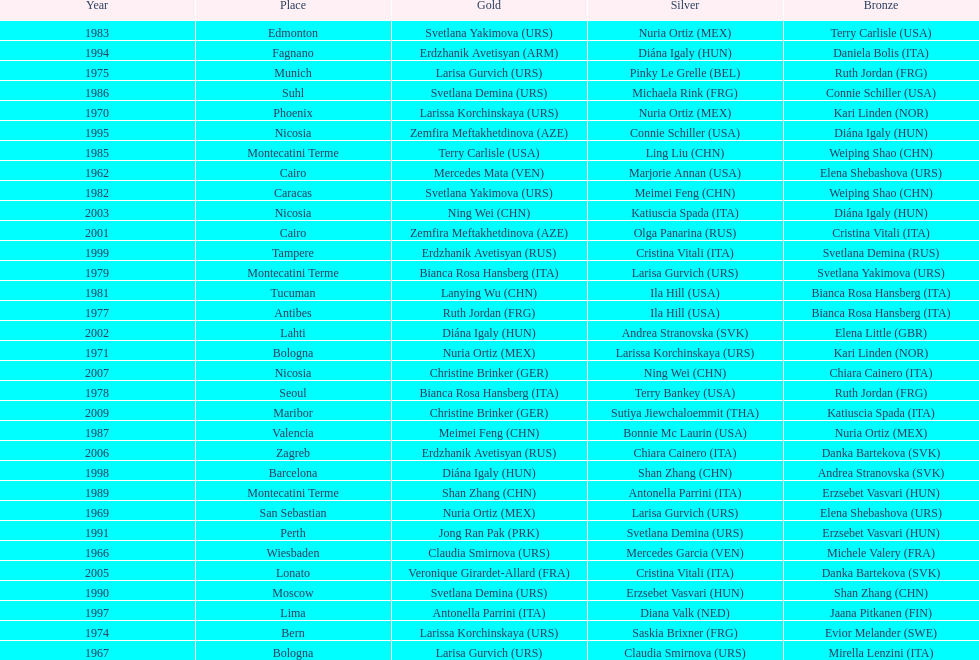What is the total of silver for cairo 0. Could you parse the entire table as a dict? {'header': ['Year', 'Place', 'Gold', 'Silver', 'Bronze'], 'rows': [['1983', 'Edmonton', 'Svetlana Yakimova\xa0(URS)', 'Nuria Ortiz\xa0(MEX)', 'Terry Carlisle\xa0(USA)'], ['1994', 'Fagnano', 'Erdzhanik Avetisyan\xa0(ARM)', 'Diána Igaly\xa0(HUN)', 'Daniela Bolis\xa0(ITA)'], ['1975', 'Munich', 'Larisa Gurvich\xa0(URS)', 'Pinky Le Grelle\xa0(BEL)', 'Ruth Jordan\xa0(FRG)'], ['1986', 'Suhl', 'Svetlana Demina\xa0(URS)', 'Michaela Rink\xa0(FRG)', 'Connie Schiller\xa0(USA)'], ['1970', 'Phoenix', 'Larissa Korchinskaya\xa0(URS)', 'Nuria Ortiz\xa0(MEX)', 'Kari Linden\xa0(NOR)'], ['1995', 'Nicosia', 'Zemfira Meftakhetdinova\xa0(AZE)', 'Connie Schiller\xa0(USA)', 'Diána Igaly\xa0(HUN)'], ['1985', 'Montecatini Terme', 'Terry Carlisle\xa0(USA)', 'Ling Liu\xa0(CHN)', 'Weiping Shao\xa0(CHN)'], ['1962', 'Cairo', 'Mercedes Mata\xa0(VEN)', 'Marjorie Annan\xa0(USA)', 'Elena Shebashova\xa0(URS)'], ['1982', 'Caracas', 'Svetlana Yakimova\xa0(URS)', 'Meimei Feng\xa0(CHN)', 'Weiping Shao\xa0(CHN)'], ['2003', 'Nicosia', 'Ning Wei\xa0(CHN)', 'Katiuscia Spada\xa0(ITA)', 'Diána Igaly\xa0(HUN)'], ['2001', 'Cairo', 'Zemfira Meftakhetdinova\xa0(AZE)', 'Olga Panarina\xa0(RUS)', 'Cristina Vitali\xa0(ITA)'], ['1999', 'Tampere', 'Erdzhanik Avetisyan\xa0(RUS)', 'Cristina Vitali\xa0(ITA)', 'Svetlana Demina\xa0(RUS)'], ['1979', 'Montecatini Terme', 'Bianca Rosa Hansberg\xa0(ITA)', 'Larisa Gurvich\xa0(URS)', 'Svetlana Yakimova\xa0(URS)'], ['1981', 'Tucuman', 'Lanying Wu\xa0(CHN)', 'Ila Hill\xa0(USA)', 'Bianca Rosa Hansberg\xa0(ITA)'], ['1977', 'Antibes', 'Ruth Jordan\xa0(FRG)', 'Ila Hill\xa0(USA)', 'Bianca Rosa Hansberg\xa0(ITA)'], ['2002', 'Lahti', 'Diána Igaly\xa0(HUN)', 'Andrea Stranovska\xa0(SVK)', 'Elena Little\xa0(GBR)'], ['1971', 'Bologna', 'Nuria Ortiz\xa0(MEX)', 'Larissa Korchinskaya\xa0(URS)', 'Kari Linden\xa0(NOR)'], ['2007', 'Nicosia', 'Christine Brinker\xa0(GER)', 'Ning Wei\xa0(CHN)', 'Chiara Cainero\xa0(ITA)'], ['1978', 'Seoul', 'Bianca Rosa Hansberg\xa0(ITA)', 'Terry Bankey\xa0(USA)', 'Ruth Jordan\xa0(FRG)'], ['2009', 'Maribor', 'Christine Brinker\xa0(GER)', 'Sutiya Jiewchaloemmit\xa0(THA)', 'Katiuscia Spada\xa0(ITA)'], ['1987', 'Valencia', 'Meimei Feng\xa0(CHN)', 'Bonnie Mc Laurin\xa0(USA)', 'Nuria Ortiz\xa0(MEX)'], ['2006', 'Zagreb', 'Erdzhanik Avetisyan\xa0(RUS)', 'Chiara Cainero\xa0(ITA)', 'Danka Bartekova\xa0(SVK)'], ['1998', 'Barcelona', 'Diána Igaly\xa0(HUN)', 'Shan Zhang\xa0(CHN)', 'Andrea Stranovska\xa0(SVK)'], ['1989', 'Montecatini Terme', 'Shan Zhang\xa0(CHN)', 'Antonella Parrini\xa0(ITA)', 'Erzsebet Vasvari\xa0(HUN)'], ['1969', 'San Sebastian', 'Nuria Ortiz\xa0(MEX)', 'Larisa Gurvich\xa0(URS)', 'Elena Shebashova\xa0(URS)'], ['1991', 'Perth', 'Jong Ran Pak\xa0(PRK)', 'Svetlana Demina\xa0(URS)', 'Erzsebet Vasvari\xa0(HUN)'], ['1966', 'Wiesbaden', 'Claudia Smirnova\xa0(URS)', 'Mercedes Garcia\xa0(VEN)', 'Michele Valery\xa0(FRA)'], ['2005', 'Lonato', 'Veronique Girardet-Allard\xa0(FRA)', 'Cristina Vitali\xa0(ITA)', 'Danka Bartekova\xa0(SVK)'], ['1990', 'Moscow', 'Svetlana Demina\xa0(URS)', 'Erzsebet Vasvari\xa0(HUN)', 'Shan Zhang\xa0(CHN)'], ['1997', 'Lima', 'Antonella Parrini\xa0(ITA)', 'Diana Valk\xa0(NED)', 'Jaana Pitkanen\xa0(FIN)'], ['1974', 'Bern', 'Larissa Korchinskaya\xa0(URS)', 'Saskia Brixner\xa0(FRG)', 'Evior Melander\xa0(SWE)'], ['1967', 'Bologna', 'Larisa Gurvich\xa0(URS)', 'Claudia Smirnova\xa0(URS)', 'Mirella Lenzini\xa0(ITA)']]} 